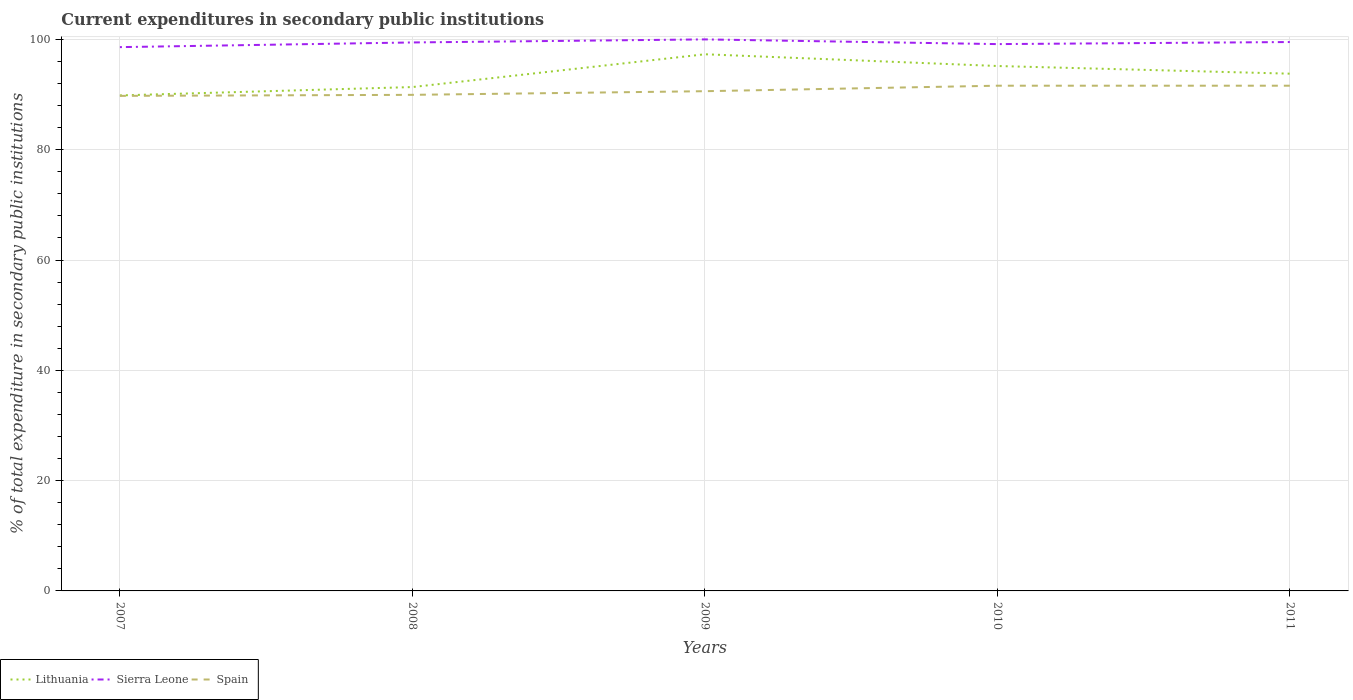How many different coloured lines are there?
Your response must be concise. 3. Is the number of lines equal to the number of legend labels?
Provide a short and direct response. Yes. Across all years, what is the maximum current expenditures in secondary public institutions in Spain?
Provide a succinct answer. 89.76. What is the total current expenditures in secondary public institutions in Lithuania in the graph?
Offer a very short reply. 1.39. What is the difference between the highest and the second highest current expenditures in secondary public institutions in Lithuania?
Ensure brevity in your answer.  7.46. How many lines are there?
Your response must be concise. 3. What is the difference between two consecutive major ticks on the Y-axis?
Offer a terse response. 20. Does the graph contain grids?
Offer a very short reply. Yes. How many legend labels are there?
Offer a very short reply. 3. What is the title of the graph?
Keep it short and to the point. Current expenditures in secondary public institutions. Does "New Caledonia" appear as one of the legend labels in the graph?
Ensure brevity in your answer.  No. What is the label or title of the Y-axis?
Offer a terse response. % of total expenditure in secondary public institutions. What is the % of total expenditure in secondary public institutions in Lithuania in 2007?
Offer a terse response. 89.84. What is the % of total expenditure in secondary public institutions of Sierra Leone in 2007?
Give a very brief answer. 98.6. What is the % of total expenditure in secondary public institutions in Spain in 2007?
Ensure brevity in your answer.  89.76. What is the % of total expenditure in secondary public institutions of Lithuania in 2008?
Make the answer very short. 91.36. What is the % of total expenditure in secondary public institutions in Sierra Leone in 2008?
Give a very brief answer. 99.45. What is the % of total expenditure in secondary public institutions in Spain in 2008?
Ensure brevity in your answer.  89.95. What is the % of total expenditure in secondary public institutions of Lithuania in 2009?
Give a very brief answer. 97.3. What is the % of total expenditure in secondary public institutions of Sierra Leone in 2009?
Your answer should be compact. 100. What is the % of total expenditure in secondary public institutions in Spain in 2009?
Your response must be concise. 90.61. What is the % of total expenditure in secondary public institutions in Lithuania in 2010?
Make the answer very short. 95.18. What is the % of total expenditure in secondary public institutions of Sierra Leone in 2010?
Ensure brevity in your answer.  99.15. What is the % of total expenditure in secondary public institutions of Spain in 2010?
Keep it short and to the point. 91.61. What is the % of total expenditure in secondary public institutions of Lithuania in 2011?
Provide a succinct answer. 93.78. What is the % of total expenditure in secondary public institutions of Sierra Leone in 2011?
Provide a succinct answer. 99.52. What is the % of total expenditure in secondary public institutions of Spain in 2011?
Offer a very short reply. 91.61. Across all years, what is the maximum % of total expenditure in secondary public institutions in Lithuania?
Provide a short and direct response. 97.3. Across all years, what is the maximum % of total expenditure in secondary public institutions of Spain?
Provide a succinct answer. 91.61. Across all years, what is the minimum % of total expenditure in secondary public institutions in Lithuania?
Your answer should be compact. 89.84. Across all years, what is the minimum % of total expenditure in secondary public institutions in Sierra Leone?
Your answer should be compact. 98.6. Across all years, what is the minimum % of total expenditure in secondary public institutions of Spain?
Keep it short and to the point. 89.76. What is the total % of total expenditure in secondary public institutions of Lithuania in the graph?
Provide a succinct answer. 467.47. What is the total % of total expenditure in secondary public institutions in Sierra Leone in the graph?
Make the answer very short. 496.72. What is the total % of total expenditure in secondary public institutions of Spain in the graph?
Your answer should be compact. 453.53. What is the difference between the % of total expenditure in secondary public institutions in Lithuania in 2007 and that in 2008?
Offer a terse response. -1.52. What is the difference between the % of total expenditure in secondary public institutions of Sierra Leone in 2007 and that in 2008?
Offer a very short reply. -0.85. What is the difference between the % of total expenditure in secondary public institutions in Spain in 2007 and that in 2008?
Offer a terse response. -0.19. What is the difference between the % of total expenditure in secondary public institutions of Lithuania in 2007 and that in 2009?
Offer a very short reply. -7.46. What is the difference between the % of total expenditure in secondary public institutions of Sierra Leone in 2007 and that in 2009?
Offer a very short reply. -1.4. What is the difference between the % of total expenditure in secondary public institutions in Spain in 2007 and that in 2009?
Keep it short and to the point. -0.85. What is the difference between the % of total expenditure in secondary public institutions in Lithuania in 2007 and that in 2010?
Ensure brevity in your answer.  -5.33. What is the difference between the % of total expenditure in secondary public institutions in Sierra Leone in 2007 and that in 2010?
Offer a very short reply. -0.55. What is the difference between the % of total expenditure in secondary public institutions of Spain in 2007 and that in 2010?
Your answer should be very brief. -1.85. What is the difference between the % of total expenditure in secondary public institutions of Lithuania in 2007 and that in 2011?
Make the answer very short. -3.94. What is the difference between the % of total expenditure in secondary public institutions in Sierra Leone in 2007 and that in 2011?
Your answer should be compact. -0.92. What is the difference between the % of total expenditure in secondary public institutions of Spain in 2007 and that in 2011?
Your answer should be compact. -1.85. What is the difference between the % of total expenditure in secondary public institutions of Lithuania in 2008 and that in 2009?
Your answer should be very brief. -5.94. What is the difference between the % of total expenditure in secondary public institutions of Sierra Leone in 2008 and that in 2009?
Offer a very short reply. -0.55. What is the difference between the % of total expenditure in secondary public institutions in Spain in 2008 and that in 2009?
Your answer should be very brief. -0.66. What is the difference between the % of total expenditure in secondary public institutions in Lithuania in 2008 and that in 2010?
Ensure brevity in your answer.  -3.82. What is the difference between the % of total expenditure in secondary public institutions in Sierra Leone in 2008 and that in 2010?
Give a very brief answer. 0.3. What is the difference between the % of total expenditure in secondary public institutions in Spain in 2008 and that in 2010?
Offer a very short reply. -1.66. What is the difference between the % of total expenditure in secondary public institutions in Lithuania in 2008 and that in 2011?
Ensure brevity in your answer.  -2.42. What is the difference between the % of total expenditure in secondary public institutions in Sierra Leone in 2008 and that in 2011?
Keep it short and to the point. -0.08. What is the difference between the % of total expenditure in secondary public institutions in Spain in 2008 and that in 2011?
Offer a very short reply. -1.66. What is the difference between the % of total expenditure in secondary public institutions in Lithuania in 2009 and that in 2010?
Provide a short and direct response. 2.13. What is the difference between the % of total expenditure in secondary public institutions in Sierra Leone in 2009 and that in 2010?
Offer a terse response. 0.85. What is the difference between the % of total expenditure in secondary public institutions in Spain in 2009 and that in 2010?
Keep it short and to the point. -1. What is the difference between the % of total expenditure in secondary public institutions of Lithuania in 2009 and that in 2011?
Provide a short and direct response. 3.52. What is the difference between the % of total expenditure in secondary public institutions of Sierra Leone in 2009 and that in 2011?
Provide a succinct answer. 0.48. What is the difference between the % of total expenditure in secondary public institutions of Spain in 2009 and that in 2011?
Keep it short and to the point. -1. What is the difference between the % of total expenditure in secondary public institutions in Lithuania in 2010 and that in 2011?
Make the answer very short. 1.39. What is the difference between the % of total expenditure in secondary public institutions in Sierra Leone in 2010 and that in 2011?
Offer a terse response. -0.38. What is the difference between the % of total expenditure in secondary public institutions of Lithuania in 2007 and the % of total expenditure in secondary public institutions of Sierra Leone in 2008?
Your response must be concise. -9.6. What is the difference between the % of total expenditure in secondary public institutions of Lithuania in 2007 and the % of total expenditure in secondary public institutions of Spain in 2008?
Give a very brief answer. -0.1. What is the difference between the % of total expenditure in secondary public institutions of Sierra Leone in 2007 and the % of total expenditure in secondary public institutions of Spain in 2008?
Your answer should be very brief. 8.65. What is the difference between the % of total expenditure in secondary public institutions in Lithuania in 2007 and the % of total expenditure in secondary public institutions in Sierra Leone in 2009?
Offer a terse response. -10.16. What is the difference between the % of total expenditure in secondary public institutions of Lithuania in 2007 and the % of total expenditure in secondary public institutions of Spain in 2009?
Your answer should be compact. -0.77. What is the difference between the % of total expenditure in secondary public institutions of Sierra Leone in 2007 and the % of total expenditure in secondary public institutions of Spain in 2009?
Offer a terse response. 7.99. What is the difference between the % of total expenditure in secondary public institutions in Lithuania in 2007 and the % of total expenditure in secondary public institutions in Sierra Leone in 2010?
Make the answer very short. -9.3. What is the difference between the % of total expenditure in secondary public institutions of Lithuania in 2007 and the % of total expenditure in secondary public institutions of Spain in 2010?
Your answer should be compact. -1.76. What is the difference between the % of total expenditure in secondary public institutions of Sierra Leone in 2007 and the % of total expenditure in secondary public institutions of Spain in 2010?
Your answer should be very brief. 6.99. What is the difference between the % of total expenditure in secondary public institutions in Lithuania in 2007 and the % of total expenditure in secondary public institutions in Sierra Leone in 2011?
Offer a very short reply. -9.68. What is the difference between the % of total expenditure in secondary public institutions of Lithuania in 2007 and the % of total expenditure in secondary public institutions of Spain in 2011?
Your answer should be compact. -1.76. What is the difference between the % of total expenditure in secondary public institutions in Sierra Leone in 2007 and the % of total expenditure in secondary public institutions in Spain in 2011?
Your answer should be very brief. 6.99. What is the difference between the % of total expenditure in secondary public institutions of Lithuania in 2008 and the % of total expenditure in secondary public institutions of Sierra Leone in 2009?
Your answer should be compact. -8.64. What is the difference between the % of total expenditure in secondary public institutions of Lithuania in 2008 and the % of total expenditure in secondary public institutions of Spain in 2009?
Provide a succinct answer. 0.75. What is the difference between the % of total expenditure in secondary public institutions of Sierra Leone in 2008 and the % of total expenditure in secondary public institutions of Spain in 2009?
Provide a succinct answer. 8.84. What is the difference between the % of total expenditure in secondary public institutions in Lithuania in 2008 and the % of total expenditure in secondary public institutions in Sierra Leone in 2010?
Your answer should be compact. -7.79. What is the difference between the % of total expenditure in secondary public institutions in Lithuania in 2008 and the % of total expenditure in secondary public institutions in Spain in 2010?
Provide a succinct answer. -0.25. What is the difference between the % of total expenditure in secondary public institutions in Sierra Leone in 2008 and the % of total expenditure in secondary public institutions in Spain in 2010?
Provide a short and direct response. 7.84. What is the difference between the % of total expenditure in secondary public institutions of Lithuania in 2008 and the % of total expenditure in secondary public institutions of Sierra Leone in 2011?
Provide a short and direct response. -8.16. What is the difference between the % of total expenditure in secondary public institutions in Lithuania in 2008 and the % of total expenditure in secondary public institutions in Spain in 2011?
Your answer should be very brief. -0.25. What is the difference between the % of total expenditure in secondary public institutions of Sierra Leone in 2008 and the % of total expenditure in secondary public institutions of Spain in 2011?
Your answer should be very brief. 7.84. What is the difference between the % of total expenditure in secondary public institutions in Lithuania in 2009 and the % of total expenditure in secondary public institutions in Sierra Leone in 2010?
Ensure brevity in your answer.  -1.84. What is the difference between the % of total expenditure in secondary public institutions in Lithuania in 2009 and the % of total expenditure in secondary public institutions in Spain in 2010?
Offer a terse response. 5.7. What is the difference between the % of total expenditure in secondary public institutions of Sierra Leone in 2009 and the % of total expenditure in secondary public institutions of Spain in 2010?
Provide a short and direct response. 8.39. What is the difference between the % of total expenditure in secondary public institutions of Lithuania in 2009 and the % of total expenditure in secondary public institutions of Sierra Leone in 2011?
Give a very brief answer. -2.22. What is the difference between the % of total expenditure in secondary public institutions in Lithuania in 2009 and the % of total expenditure in secondary public institutions in Spain in 2011?
Make the answer very short. 5.7. What is the difference between the % of total expenditure in secondary public institutions in Sierra Leone in 2009 and the % of total expenditure in secondary public institutions in Spain in 2011?
Provide a short and direct response. 8.39. What is the difference between the % of total expenditure in secondary public institutions of Lithuania in 2010 and the % of total expenditure in secondary public institutions of Sierra Leone in 2011?
Give a very brief answer. -4.35. What is the difference between the % of total expenditure in secondary public institutions of Lithuania in 2010 and the % of total expenditure in secondary public institutions of Spain in 2011?
Offer a terse response. 3.57. What is the difference between the % of total expenditure in secondary public institutions in Sierra Leone in 2010 and the % of total expenditure in secondary public institutions in Spain in 2011?
Provide a succinct answer. 7.54. What is the average % of total expenditure in secondary public institutions of Lithuania per year?
Make the answer very short. 93.49. What is the average % of total expenditure in secondary public institutions in Sierra Leone per year?
Your response must be concise. 99.34. What is the average % of total expenditure in secondary public institutions in Spain per year?
Your answer should be very brief. 90.71. In the year 2007, what is the difference between the % of total expenditure in secondary public institutions of Lithuania and % of total expenditure in secondary public institutions of Sierra Leone?
Provide a succinct answer. -8.76. In the year 2007, what is the difference between the % of total expenditure in secondary public institutions of Lithuania and % of total expenditure in secondary public institutions of Spain?
Your response must be concise. 0.08. In the year 2007, what is the difference between the % of total expenditure in secondary public institutions in Sierra Leone and % of total expenditure in secondary public institutions in Spain?
Make the answer very short. 8.84. In the year 2008, what is the difference between the % of total expenditure in secondary public institutions in Lithuania and % of total expenditure in secondary public institutions in Sierra Leone?
Ensure brevity in your answer.  -8.09. In the year 2008, what is the difference between the % of total expenditure in secondary public institutions of Lithuania and % of total expenditure in secondary public institutions of Spain?
Offer a very short reply. 1.41. In the year 2008, what is the difference between the % of total expenditure in secondary public institutions of Sierra Leone and % of total expenditure in secondary public institutions of Spain?
Ensure brevity in your answer.  9.5. In the year 2009, what is the difference between the % of total expenditure in secondary public institutions of Lithuania and % of total expenditure in secondary public institutions of Sierra Leone?
Provide a succinct answer. -2.7. In the year 2009, what is the difference between the % of total expenditure in secondary public institutions in Lithuania and % of total expenditure in secondary public institutions in Spain?
Give a very brief answer. 6.7. In the year 2009, what is the difference between the % of total expenditure in secondary public institutions in Sierra Leone and % of total expenditure in secondary public institutions in Spain?
Keep it short and to the point. 9.39. In the year 2010, what is the difference between the % of total expenditure in secondary public institutions of Lithuania and % of total expenditure in secondary public institutions of Sierra Leone?
Offer a terse response. -3.97. In the year 2010, what is the difference between the % of total expenditure in secondary public institutions in Lithuania and % of total expenditure in secondary public institutions in Spain?
Provide a short and direct response. 3.57. In the year 2010, what is the difference between the % of total expenditure in secondary public institutions of Sierra Leone and % of total expenditure in secondary public institutions of Spain?
Offer a very short reply. 7.54. In the year 2011, what is the difference between the % of total expenditure in secondary public institutions in Lithuania and % of total expenditure in secondary public institutions in Sierra Leone?
Your response must be concise. -5.74. In the year 2011, what is the difference between the % of total expenditure in secondary public institutions of Lithuania and % of total expenditure in secondary public institutions of Spain?
Your response must be concise. 2.18. In the year 2011, what is the difference between the % of total expenditure in secondary public institutions in Sierra Leone and % of total expenditure in secondary public institutions in Spain?
Your answer should be very brief. 7.92. What is the ratio of the % of total expenditure in secondary public institutions in Lithuania in 2007 to that in 2008?
Provide a succinct answer. 0.98. What is the ratio of the % of total expenditure in secondary public institutions of Sierra Leone in 2007 to that in 2008?
Provide a short and direct response. 0.99. What is the ratio of the % of total expenditure in secondary public institutions of Spain in 2007 to that in 2008?
Keep it short and to the point. 1. What is the ratio of the % of total expenditure in secondary public institutions of Lithuania in 2007 to that in 2009?
Offer a terse response. 0.92. What is the ratio of the % of total expenditure in secondary public institutions in Sierra Leone in 2007 to that in 2009?
Your response must be concise. 0.99. What is the ratio of the % of total expenditure in secondary public institutions of Spain in 2007 to that in 2009?
Your answer should be compact. 0.99. What is the ratio of the % of total expenditure in secondary public institutions of Lithuania in 2007 to that in 2010?
Your answer should be very brief. 0.94. What is the ratio of the % of total expenditure in secondary public institutions in Sierra Leone in 2007 to that in 2010?
Offer a terse response. 0.99. What is the ratio of the % of total expenditure in secondary public institutions in Spain in 2007 to that in 2010?
Provide a short and direct response. 0.98. What is the ratio of the % of total expenditure in secondary public institutions in Lithuania in 2007 to that in 2011?
Your answer should be compact. 0.96. What is the ratio of the % of total expenditure in secondary public institutions of Sierra Leone in 2007 to that in 2011?
Keep it short and to the point. 0.99. What is the ratio of the % of total expenditure in secondary public institutions in Spain in 2007 to that in 2011?
Provide a short and direct response. 0.98. What is the ratio of the % of total expenditure in secondary public institutions in Lithuania in 2008 to that in 2009?
Offer a very short reply. 0.94. What is the ratio of the % of total expenditure in secondary public institutions of Lithuania in 2008 to that in 2010?
Offer a terse response. 0.96. What is the ratio of the % of total expenditure in secondary public institutions of Sierra Leone in 2008 to that in 2010?
Make the answer very short. 1. What is the ratio of the % of total expenditure in secondary public institutions in Spain in 2008 to that in 2010?
Your response must be concise. 0.98. What is the ratio of the % of total expenditure in secondary public institutions in Lithuania in 2008 to that in 2011?
Ensure brevity in your answer.  0.97. What is the ratio of the % of total expenditure in secondary public institutions of Sierra Leone in 2008 to that in 2011?
Offer a very short reply. 1. What is the ratio of the % of total expenditure in secondary public institutions in Spain in 2008 to that in 2011?
Ensure brevity in your answer.  0.98. What is the ratio of the % of total expenditure in secondary public institutions of Lithuania in 2009 to that in 2010?
Your response must be concise. 1.02. What is the ratio of the % of total expenditure in secondary public institutions in Sierra Leone in 2009 to that in 2010?
Provide a short and direct response. 1.01. What is the ratio of the % of total expenditure in secondary public institutions of Spain in 2009 to that in 2010?
Your response must be concise. 0.99. What is the ratio of the % of total expenditure in secondary public institutions in Lithuania in 2009 to that in 2011?
Provide a short and direct response. 1.04. What is the ratio of the % of total expenditure in secondary public institutions in Lithuania in 2010 to that in 2011?
Offer a very short reply. 1.01. What is the difference between the highest and the second highest % of total expenditure in secondary public institutions of Lithuania?
Offer a very short reply. 2.13. What is the difference between the highest and the second highest % of total expenditure in secondary public institutions in Sierra Leone?
Give a very brief answer. 0.48. What is the difference between the highest and the lowest % of total expenditure in secondary public institutions of Lithuania?
Your answer should be compact. 7.46. What is the difference between the highest and the lowest % of total expenditure in secondary public institutions in Sierra Leone?
Provide a succinct answer. 1.4. What is the difference between the highest and the lowest % of total expenditure in secondary public institutions in Spain?
Your answer should be compact. 1.85. 